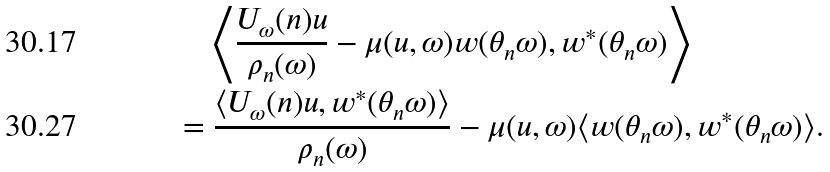<formula> <loc_0><loc_0><loc_500><loc_500>& \quad \left \langle \frac { U _ { \omega } ( n ) u } { \rho _ { n } ( \omega ) } - \mu ( u , \omega ) w ( \theta _ { n } \omega ) , w ^ { * } ( \theta _ { n } \omega ) \right \rangle \\ & = \frac { \langle U _ { \omega } ( n ) u , w ^ { * } ( \theta _ { n } \omega ) \rangle } { \rho _ { n } ( \omega ) } - \mu ( u , \omega ) \langle w ( \theta _ { n } \omega ) , w ^ { * } ( \theta _ { n } \omega ) \rangle .</formula> 